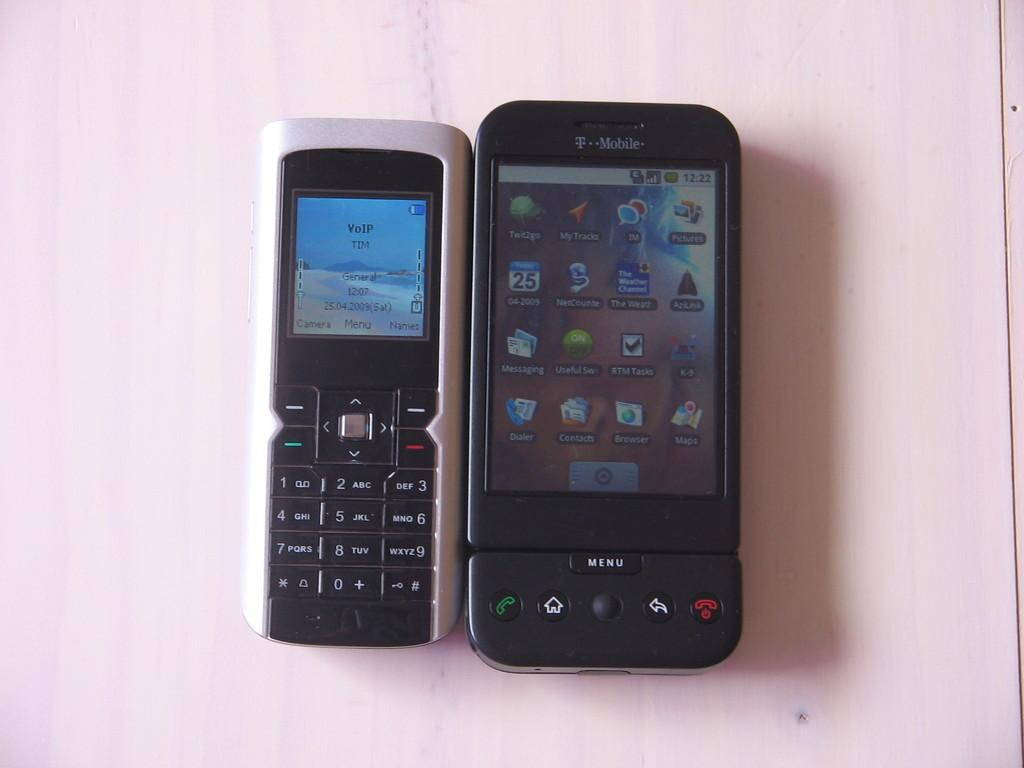<image>
Offer a succinct explanation of the picture presented. An old cell phone next to a TMobile smart phone. 